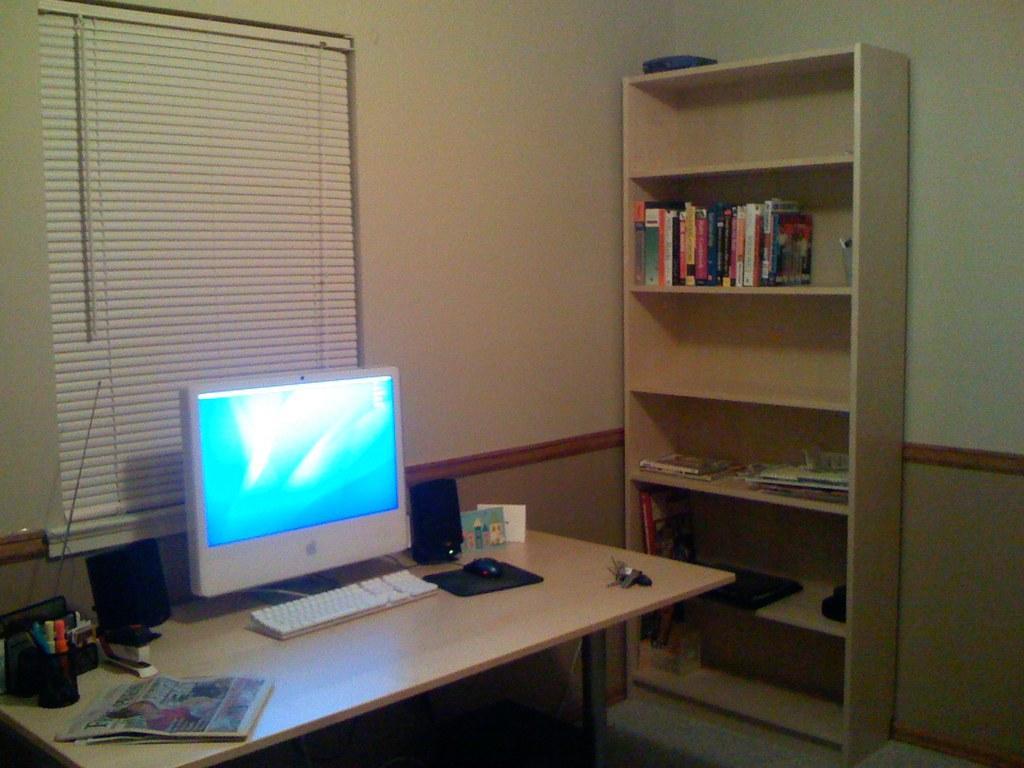In one or two sentences, can you explain what this image depicts? In this image, I can see a monitor, keyboard, computer mouse, speakers, newspapers, pens in a pen stand and few other objects on a table. On the right side of the image, there are books in the racks. Behind the table, I can see window blinds to the wall. 